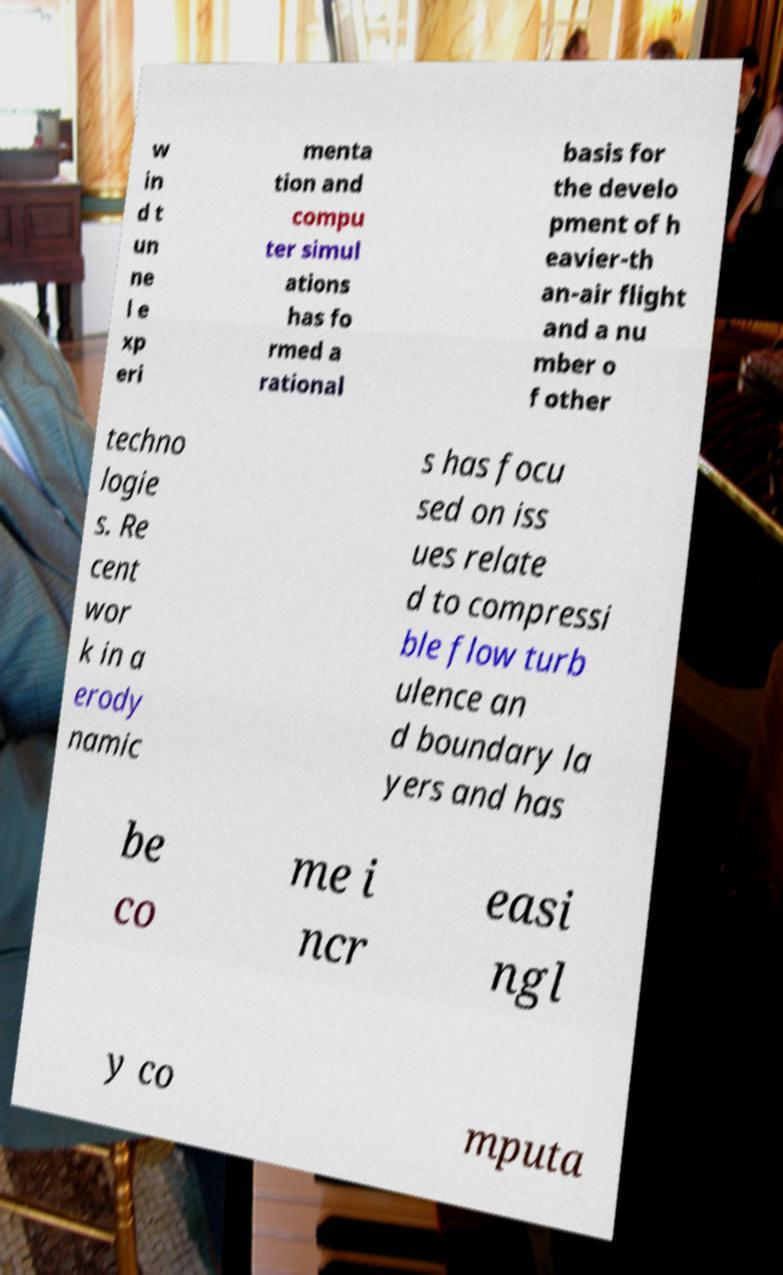Could you extract and type out the text from this image? w in d t un ne l e xp eri menta tion and compu ter simul ations has fo rmed a rational basis for the develo pment of h eavier-th an-air flight and a nu mber o f other techno logie s. Re cent wor k in a erody namic s has focu sed on iss ues relate d to compressi ble flow turb ulence an d boundary la yers and has be co me i ncr easi ngl y co mputa 